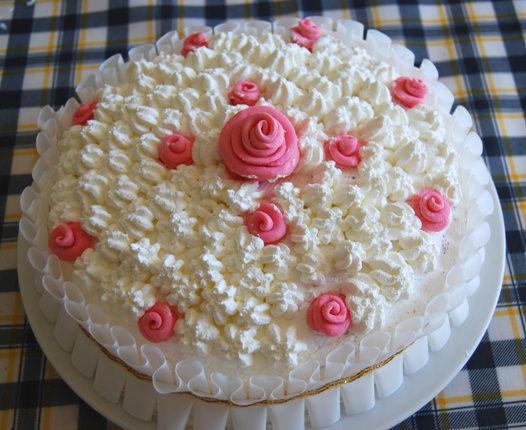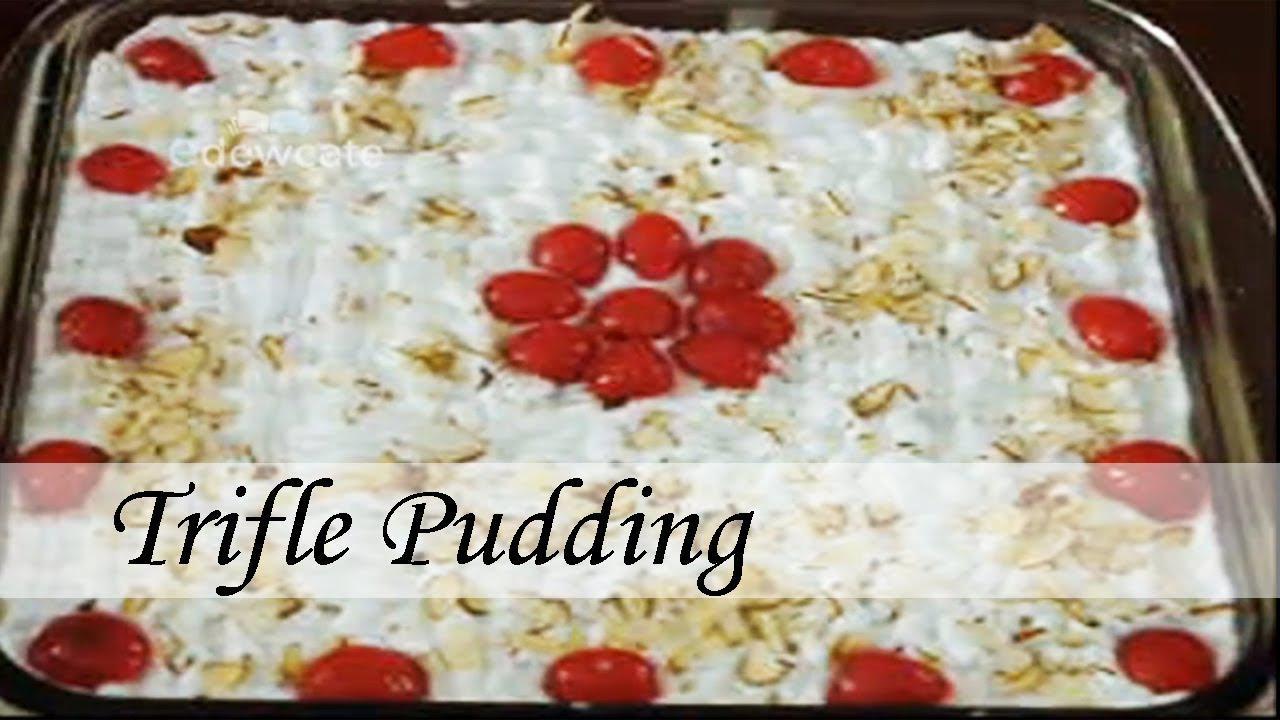The first image is the image on the left, the second image is the image on the right. Examine the images to the left and right. Is the description "The left image features a trifle garnished with thin apple slices." accurate? Answer yes or no. No. 